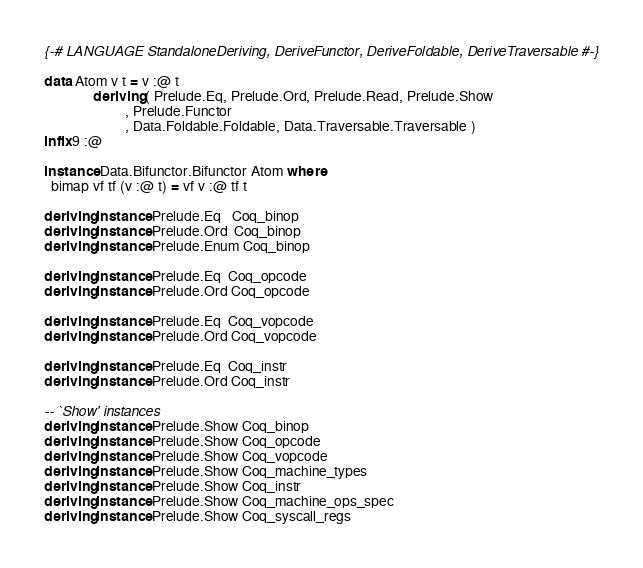Convert code to text. <code><loc_0><loc_0><loc_500><loc_500><_Haskell_>{-# LANGUAGE StandaloneDeriving, DeriveFunctor, DeriveFoldable, DeriveTraversable #-}

data Atom v t = v :@ t
              deriving ( Prelude.Eq, Prelude.Ord, Prelude.Read, Prelude.Show
                       , Prelude.Functor
                       , Data.Foldable.Foldable, Data.Traversable.Traversable )
infix 9 :@

instance Data.Bifunctor.Bifunctor Atom where
  bimap vf tf (v :@ t) = vf v :@ tf t

deriving instance Prelude.Eq   Coq_binop
deriving instance Prelude.Ord  Coq_binop
deriving instance Prelude.Enum Coq_binop

deriving instance Prelude.Eq  Coq_opcode
deriving instance Prelude.Ord Coq_opcode

deriving instance Prelude.Eq  Coq_vopcode
deriving instance Prelude.Ord Coq_vopcode

deriving instance Prelude.Eq  Coq_instr
deriving instance Prelude.Ord Coq_instr

-- `Show' instances
deriving instance Prelude.Show Coq_binop
deriving instance Prelude.Show Coq_opcode
deriving instance Prelude.Show Coq_vopcode
deriving instance Prelude.Show Coq_machine_types
deriving instance Prelude.Show Coq_instr
deriving instance Prelude.Show Coq_machine_ops_spec
deriving instance Prelude.Show Coq_syscall_regs
</code> 